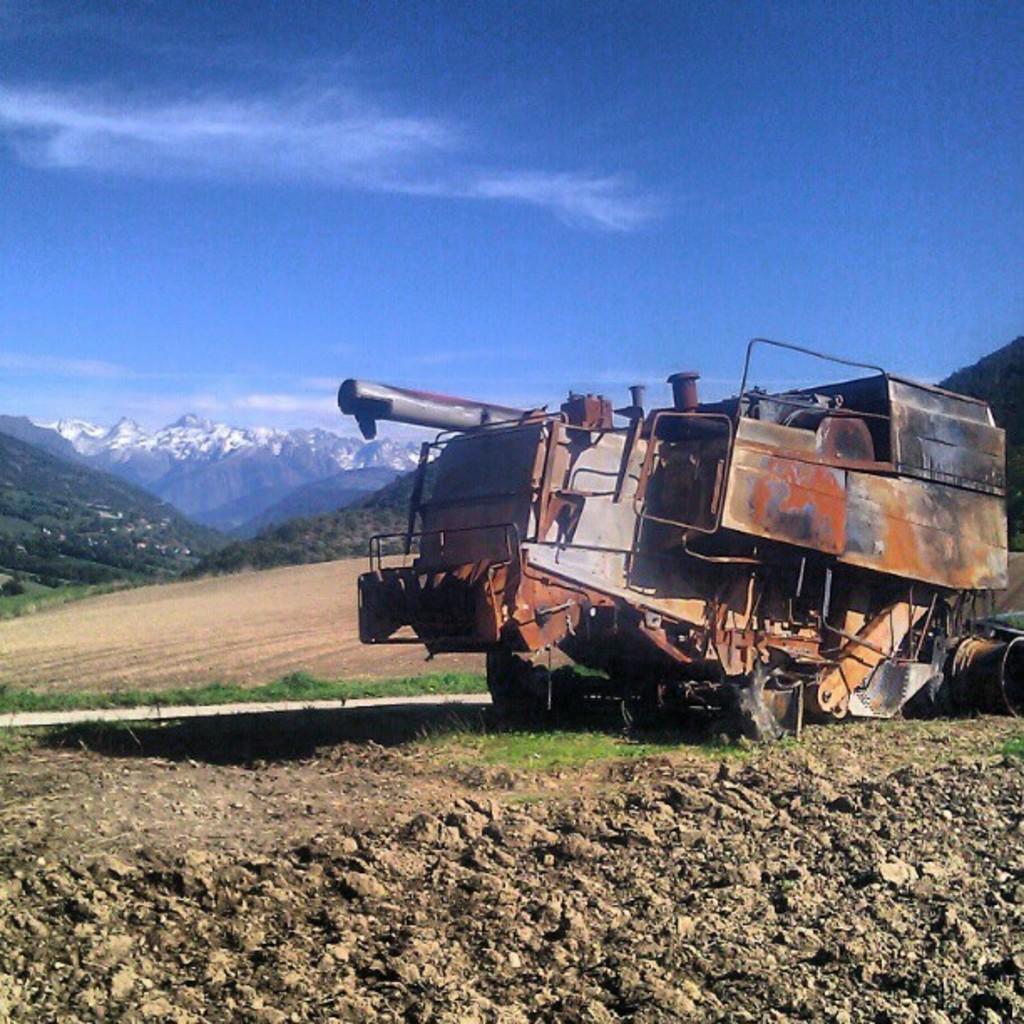Please provide a concise description of this image. At the bottom of the picture, we see the stones. On the right side, we see a vehicle in red color. Beside that, we see grass. There are trees and hills in the background. At the top of the picture, we see the sky, which is blue in color. 